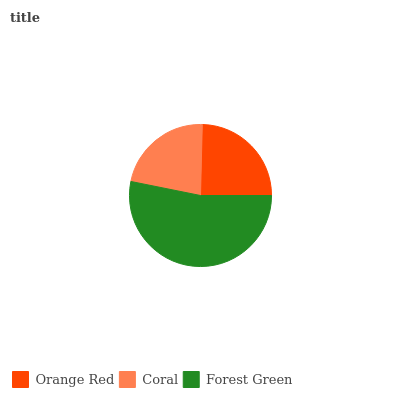Is Coral the minimum?
Answer yes or no. Yes. Is Forest Green the maximum?
Answer yes or no. Yes. Is Forest Green the minimum?
Answer yes or no. No. Is Coral the maximum?
Answer yes or no. No. Is Forest Green greater than Coral?
Answer yes or no. Yes. Is Coral less than Forest Green?
Answer yes or no. Yes. Is Coral greater than Forest Green?
Answer yes or no. No. Is Forest Green less than Coral?
Answer yes or no. No. Is Orange Red the high median?
Answer yes or no. Yes. Is Orange Red the low median?
Answer yes or no. Yes. Is Coral the high median?
Answer yes or no. No. Is Coral the low median?
Answer yes or no. No. 